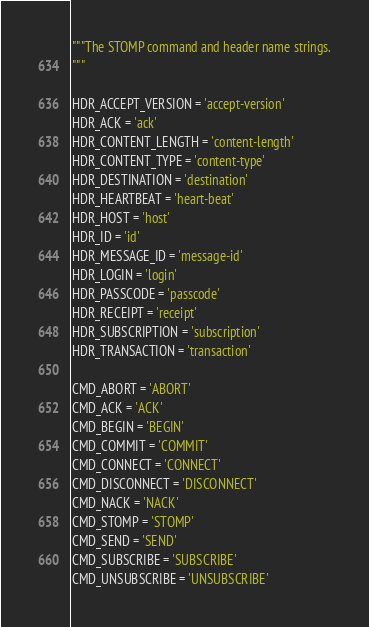Convert code to text. <code><loc_0><loc_0><loc_500><loc_500><_Python_>"""The STOMP command and header name strings.
"""

HDR_ACCEPT_VERSION = 'accept-version'
HDR_ACK = 'ack'
HDR_CONTENT_LENGTH = 'content-length'
HDR_CONTENT_TYPE = 'content-type'
HDR_DESTINATION = 'destination'
HDR_HEARTBEAT = 'heart-beat'
HDR_HOST = 'host'
HDR_ID = 'id'
HDR_MESSAGE_ID = 'message-id'
HDR_LOGIN = 'login'
HDR_PASSCODE = 'passcode'
HDR_RECEIPT = 'receipt'
HDR_SUBSCRIPTION = 'subscription'
HDR_TRANSACTION = 'transaction'

CMD_ABORT = 'ABORT'
CMD_ACK = 'ACK'
CMD_BEGIN = 'BEGIN'
CMD_COMMIT = 'COMMIT'
CMD_CONNECT = 'CONNECT'
CMD_DISCONNECT = 'DISCONNECT'
CMD_NACK = 'NACK'
CMD_STOMP = 'STOMP'
CMD_SEND = 'SEND'
CMD_SUBSCRIBE = 'SUBSCRIBE'
CMD_UNSUBSCRIBE = 'UNSUBSCRIBE'
</code> 